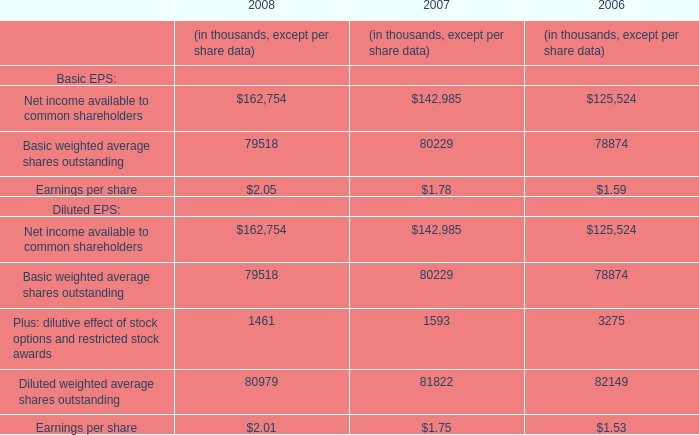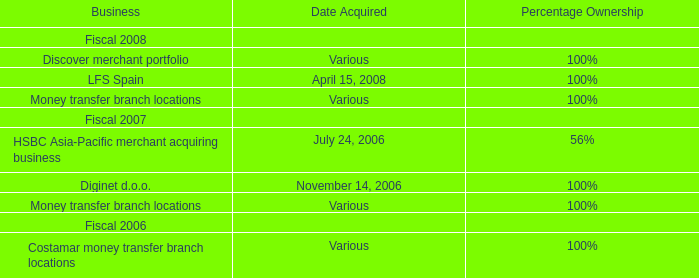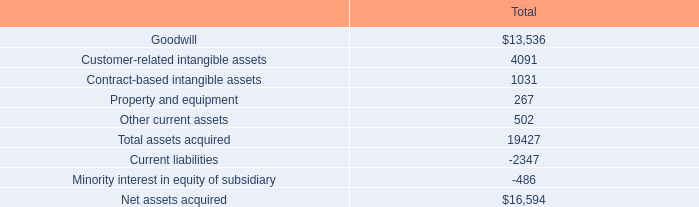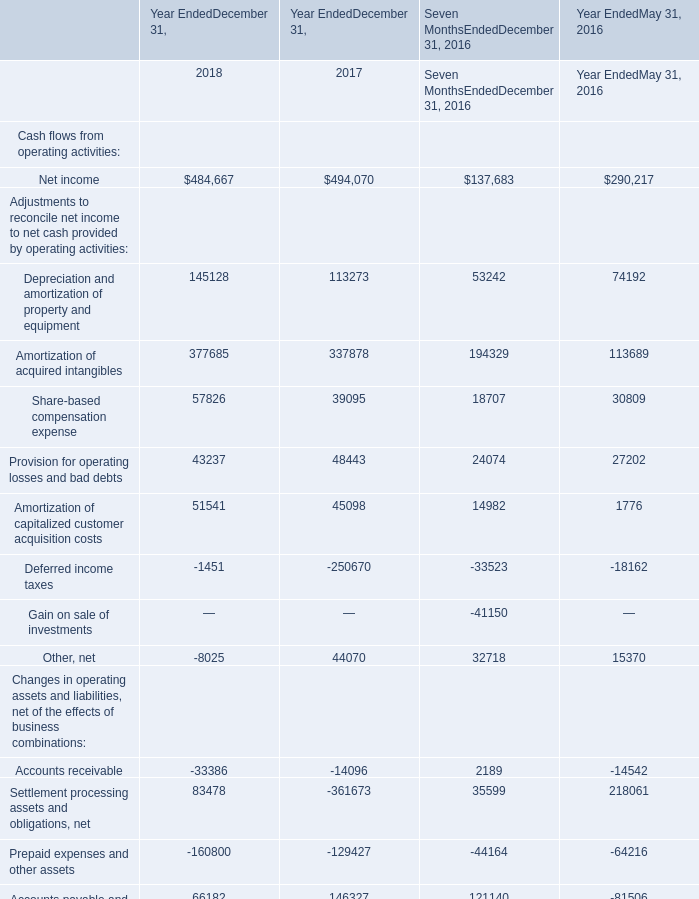In the year with the most Net income, what is the growth rate of Amortization of acquired intangibles? 
Computations: (((337878 - 194329) - 113689) / (194329 + 113689))
Answer: 0.09694. 